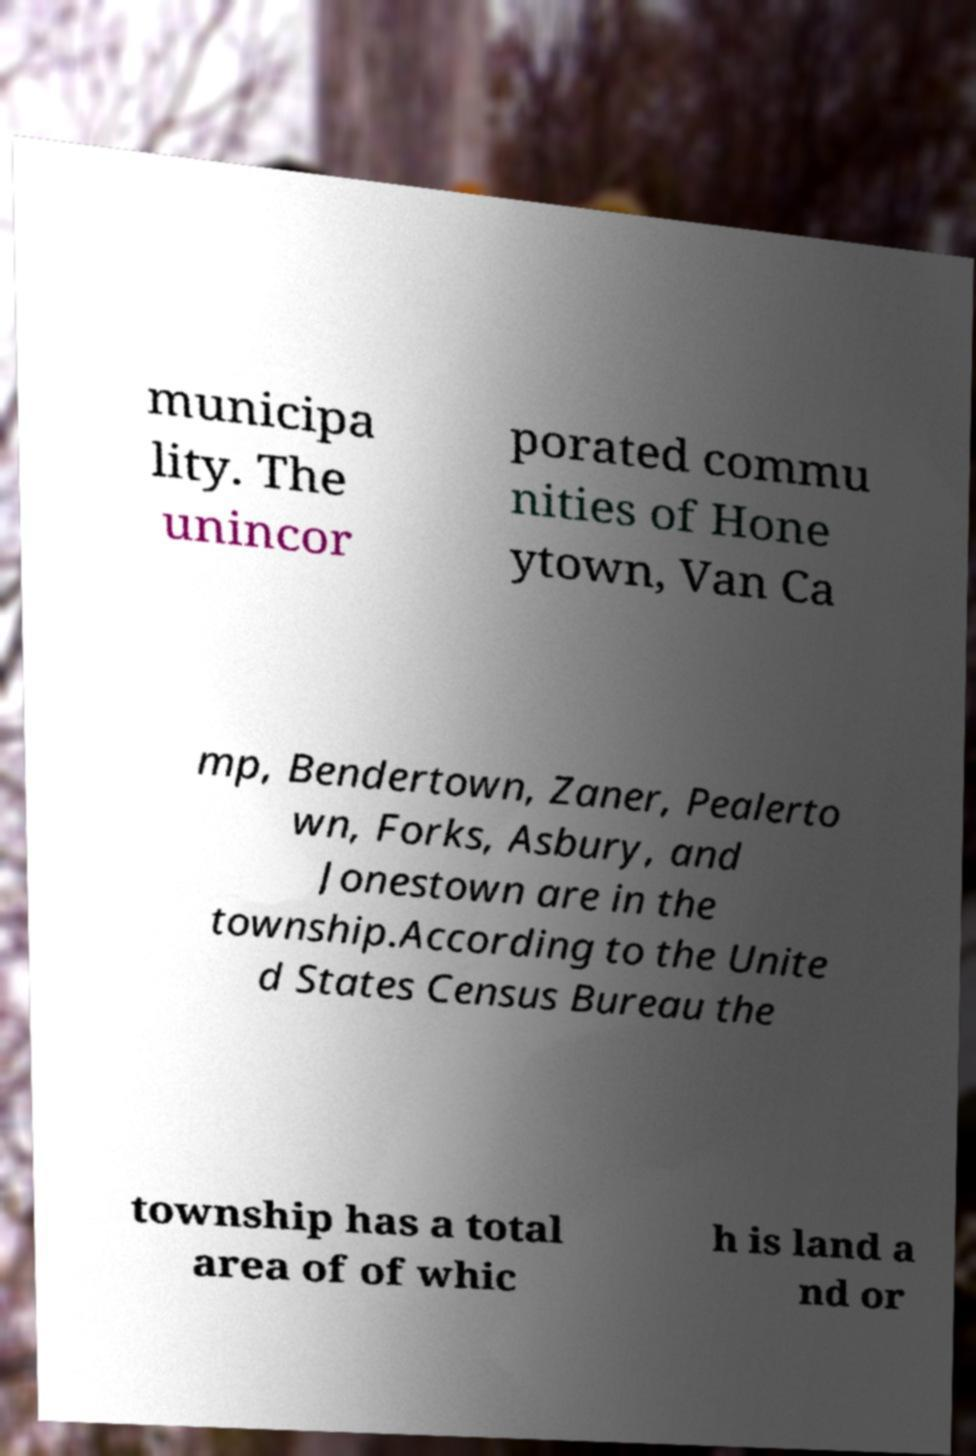There's text embedded in this image that I need extracted. Can you transcribe it verbatim? municipa lity. The unincor porated commu nities of Hone ytown, Van Ca mp, Bendertown, Zaner, Pealerto wn, Forks, Asbury, and Jonestown are in the township.According to the Unite d States Census Bureau the township has a total area of of whic h is land a nd or 